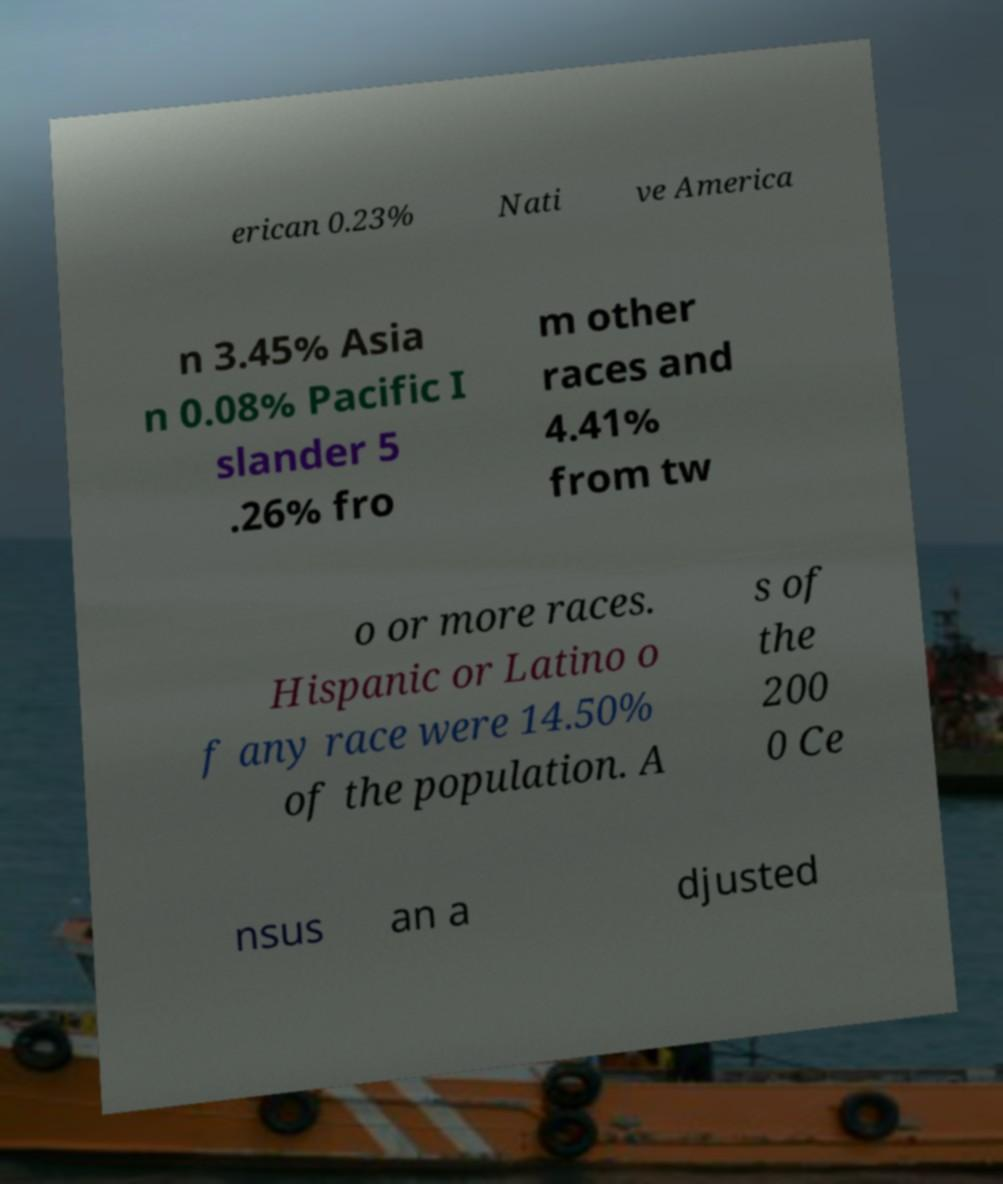I need the written content from this picture converted into text. Can you do that? erican 0.23% Nati ve America n 3.45% Asia n 0.08% Pacific I slander 5 .26% fro m other races and 4.41% from tw o or more races. Hispanic or Latino o f any race were 14.50% of the population. A s of the 200 0 Ce nsus an a djusted 